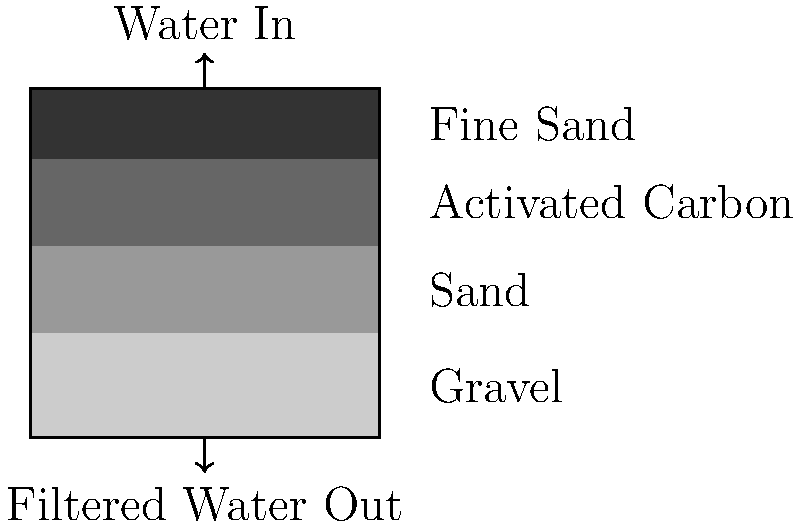As a natural materials enthusiast, you're designing a filtration system for your studio's small pond. The system consists of four layers: gravel, sand, activated carbon, and fine sand (from bottom to top). If the total height of the filtration system is 100 cm, and the ratios of layer thicknesses are 3:2.5:2.5:2, what is the thickness of the activated carbon layer in centimeters? To solve this problem, let's follow these steps:

1. Understand the given information:
   - Total height of the filtration system: 100 cm
   - Layer order from bottom to top: gravel, sand, activated carbon, fine sand
   - Ratios of layer thicknesses: 3:2.5:2.5:2

2. Calculate the sum of the ratio parts:
   $3 + 2.5 + 2.5 + 2 = 10$

3. Determine the value of one ratio part:
   $\text{One part} = \frac{\text{Total height}}{\text{Sum of ratio parts}} = \frac{100 \text{ cm}}{10} = 10 \text{ cm}$

4. Calculate the thickness of the activated carbon layer:
   $\text{Activated carbon thickness} = 2.5 \times 10 \text{ cm} = 25 \text{ cm}$

Therefore, the thickness of the activated carbon layer is 25 cm.
Answer: 25 cm 